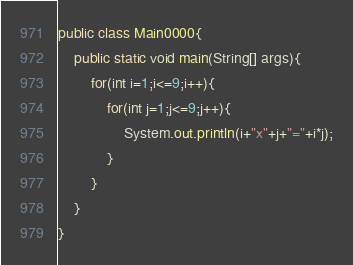Convert code to text. <code><loc_0><loc_0><loc_500><loc_500><_Java_>public class Main0000{
	public static void main(String[] args){
		for(int i=1;i<=9;i++){
			for(int j=1;j<=9;j++){
				System.out.println(i+"x"+j+"="+i*j);
			}
		}
	}
}</code> 